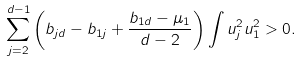<formula> <loc_0><loc_0><loc_500><loc_500>\sum _ { j = 2 } ^ { d - 1 } \left ( b _ { j d } - b _ { 1 j } + \frac { b _ { 1 d } - \mu _ { 1 } } { d - 2 } \right ) \int u _ { j } ^ { 2 } u _ { 1 } ^ { 2 } > 0 .</formula> 